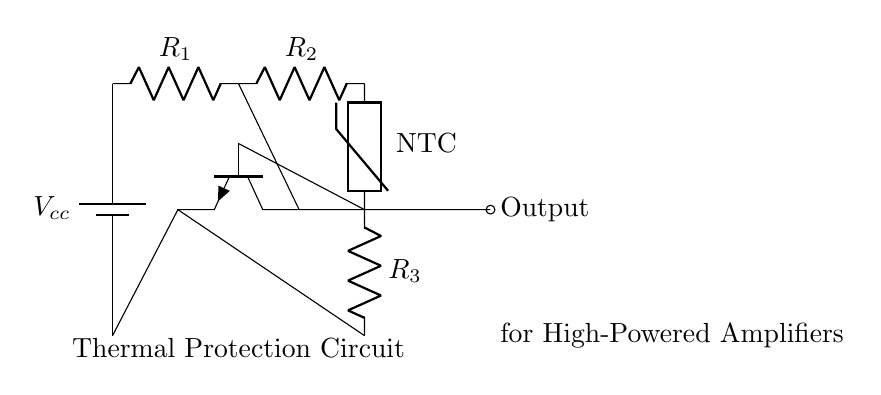What components are present in this circuit? The circuit includes a battery, an NPN transistor, a thermistor, and three resistors. These components can be identified based on standard symbols for batteries, transistors, thermistors, and resistors in the circuit diagram.
Answer: battery, NPN transistor, thermistor, resistors What type of thermistor is used in this circuit? The circuit specifically shows an NTC (Negative Temperature Coefficient) thermistor. This is indicated by the label on the thermistor symbol in the diagram, which is a standard notation for such components.
Answer: NTC What is the function of the transistor in this circuit? The transistor acts as a switch or amplifier for the thermal protection circuit, allowing it to control the output based on the thermal readings from the thermistor. Its purpose is critical for managing high thermal loads from the amplifier.
Answer: switch or amplifier How many resistors are there in the circuit? The diagram clearly shows three resistors labeled R1, R2, and R3 in the circuit. By counting the resistor symbols in the diagram, we can confirm that there are three in total.
Answer: three What role does the thermistor play in this thermal protection circuit? The thermistor monitors the temperature of the circuit. As the temperature changes, the resistance of the NTC thermistor varies, affecting the voltage at the transistor's base. This ultimately influences whether the transistor conducts or not, thus protecting the amplifier.
Answer: monitors temperature What is the output of the circuit? The output of the circuit is represented as an open circle labeled "Output" connected directly to the collector of the transistor. This indicates that the output signal is taken from the transistor, which controls the load in the high-powered amplifier.
Answer: Output What could happen if the thermistor fails in this circuit? If the thermistor fails, the circuit may not be able to detect temperature changes. This could lead to overheating of the amplifier if it continues to operate without protection, potentially damaging the amplifier components.
Answer: overheating or damage 